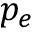<formula> <loc_0><loc_0><loc_500><loc_500>p _ { e }</formula> 